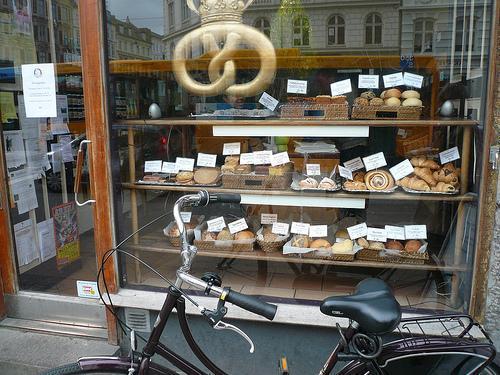How many bikes are there?
Give a very brief answer. 1. 